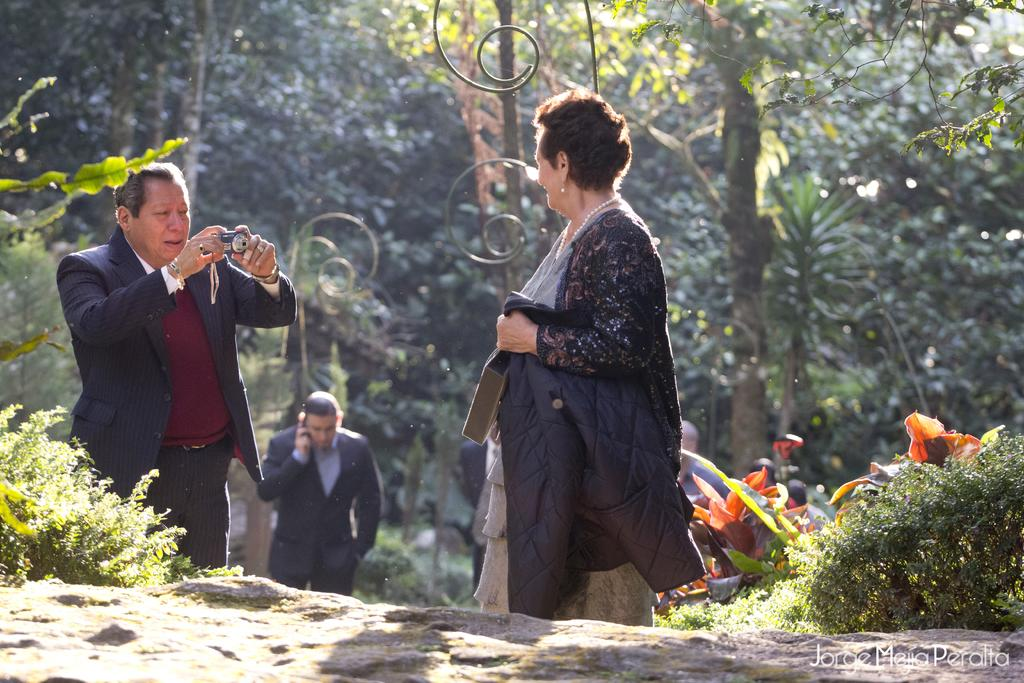Who or what can be seen in the image? There are people in the image. What else is present in the image besides the people? There are plants and rocks visible in the image. What can be seen in the background of the image? There are trees in the background of the image. How many toes can be seen on the people in the image? There is no way to determine the number of toes on the people in the image, as the image does not show their feet. 